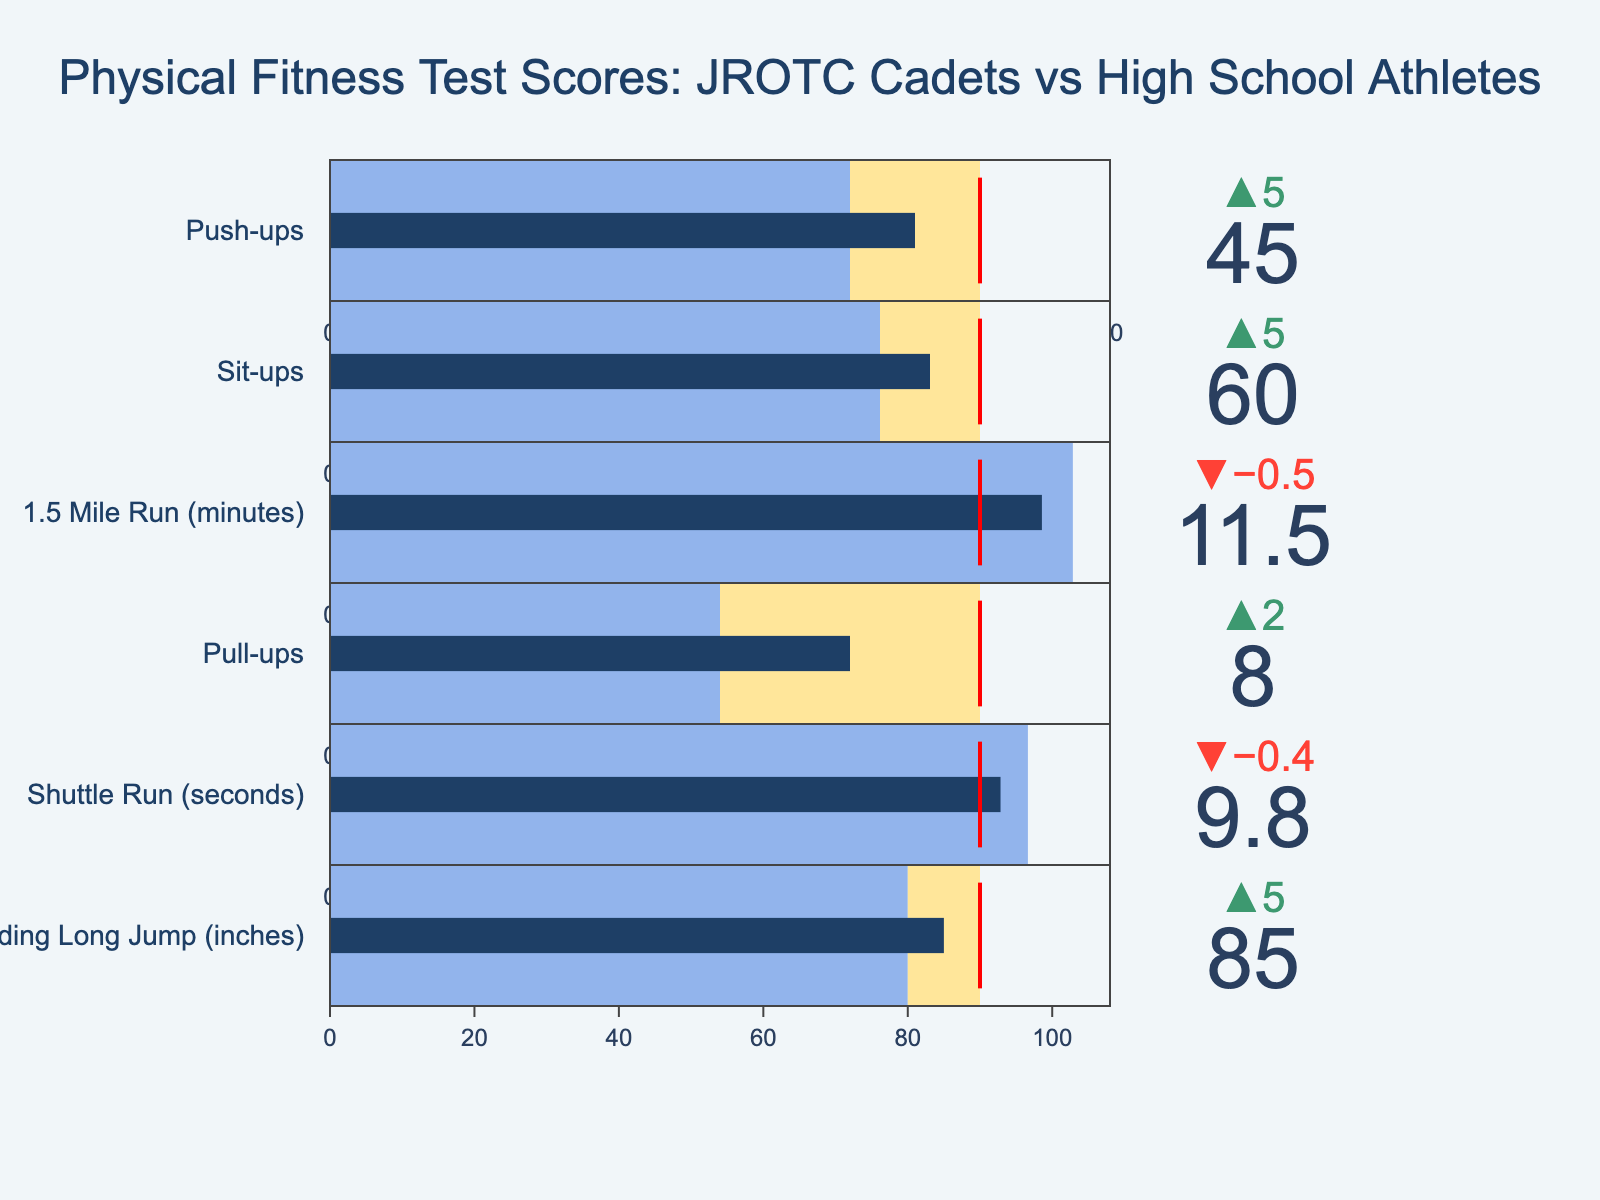What is the title of the figure? The title is usually shown at the top of the figure. It helps to quickly understand what the entire chart is about.
Answer: Physical Fitness Test Scores: JROTC Cadets vs High School Athletes How many categories are displayed in the figure? To find the number of categories, count the number of bullet charts in the figure, each representing a different exercise.
Answer: 6 What is the actual number of push-ups done by JROTC cadets? Locate the bullet chart for "Push-ups" and look at the actual score value displayed.
Answer: 45 Which category shows the highest actual score? Compare the actual values from each category and identify the highest one.
Answer: Sit-ups Which category's actual score is the closest to its target? Calculate the absolute difference between the actual score and the target score for each category, and identify the smallest difference.
Answer: Push-ups How much better did JROTC cadets perform in the Shuttle Run compared to high school athletes? Find the difference between the Shuttle Run scores for JROTC cadets and high school athletes.
Answer: 0.4 seconds Among the categories, which has the widest gap between the comparative and target values? Calculate the difference between the comparative and target values for each category and identify the one with the largest gap.
Answer: Pull-ups Are there any categories where the actual performance of JROTC cadets surpassed the target? Compare actual values with their respective target values across categories to find any instances where the actual value is greater than the target.
Answer: No In which category do high school athletes outperform JROTC cadets? Compare the actual scores of JROTC cadets to the comparative scores (high school athletes) to find any category where the comparative score is higher.
Answer: 1.5 Mile Run What's the average target score across all categories? Sum all the target values and divide by the number of categories. (50+65+10.5+10+9.5+90)/6 = 37.5
Answer: 37.5 